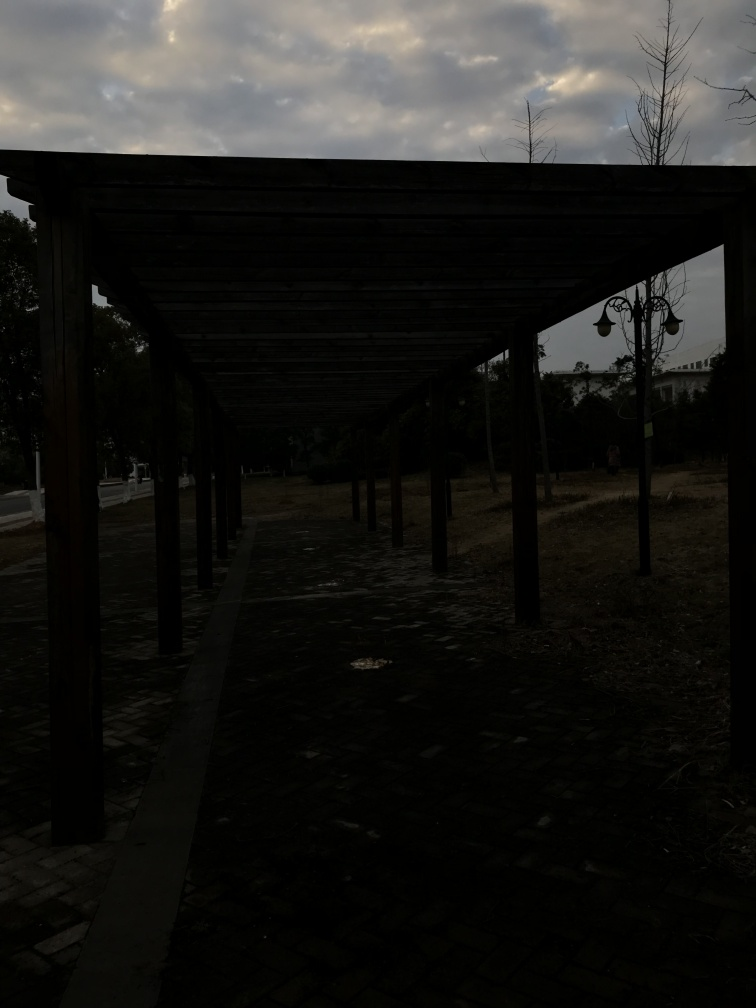What time of day does this image seem to depict? The image likely captures the early evening hours, as illustrated by the dimmed lighting and the clouds lightly tinged with sun, suggesting the sun is low on the horizon. 